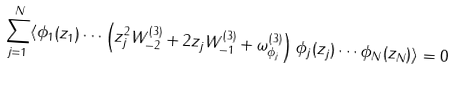<formula> <loc_0><loc_0><loc_500><loc_500>\sum _ { j = 1 } ^ { N } \langle \phi _ { 1 } ( z _ { 1 } ) \cdots \left ( z ^ { 2 } _ { j } W _ { - 2 } ^ { ( 3 ) } + 2 z _ { j } W _ { - 1 } ^ { ( 3 ) } + \omega ^ { ( 3 ) } _ { \phi _ { j } } \right ) \phi _ { j } ( z _ { j } ) \cdots \phi _ { N } ( z _ { N } ) \rangle = 0 \\</formula> 